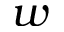<formula> <loc_0><loc_0><loc_500><loc_500>w</formula> 